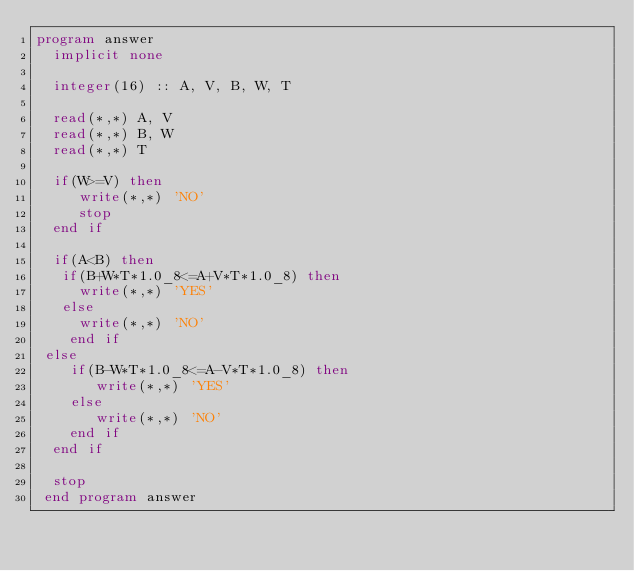<code> <loc_0><loc_0><loc_500><loc_500><_FORTRAN_>program answer
  implicit none

  integer(16) :: A, V, B, W, T

  read(*,*) A, V
  read(*,*) B, W
  read(*,*) T

  if(W>=V) then
     write(*,*) 'NO'
     stop
  end if
  
  if(A<B) then
   if(B+W*T*1.0_8<=A+V*T*1.0_8) then
     write(*,*) 'YES'
   else
     write(*,*) 'NO'
    end if
 else
    if(B-W*T*1.0_8<=A-V*T*1.0_8) then
       write(*,*) 'YES'
    else
       write(*,*) 'NO'
    end if
  end if

  stop
 end program answer
</code> 